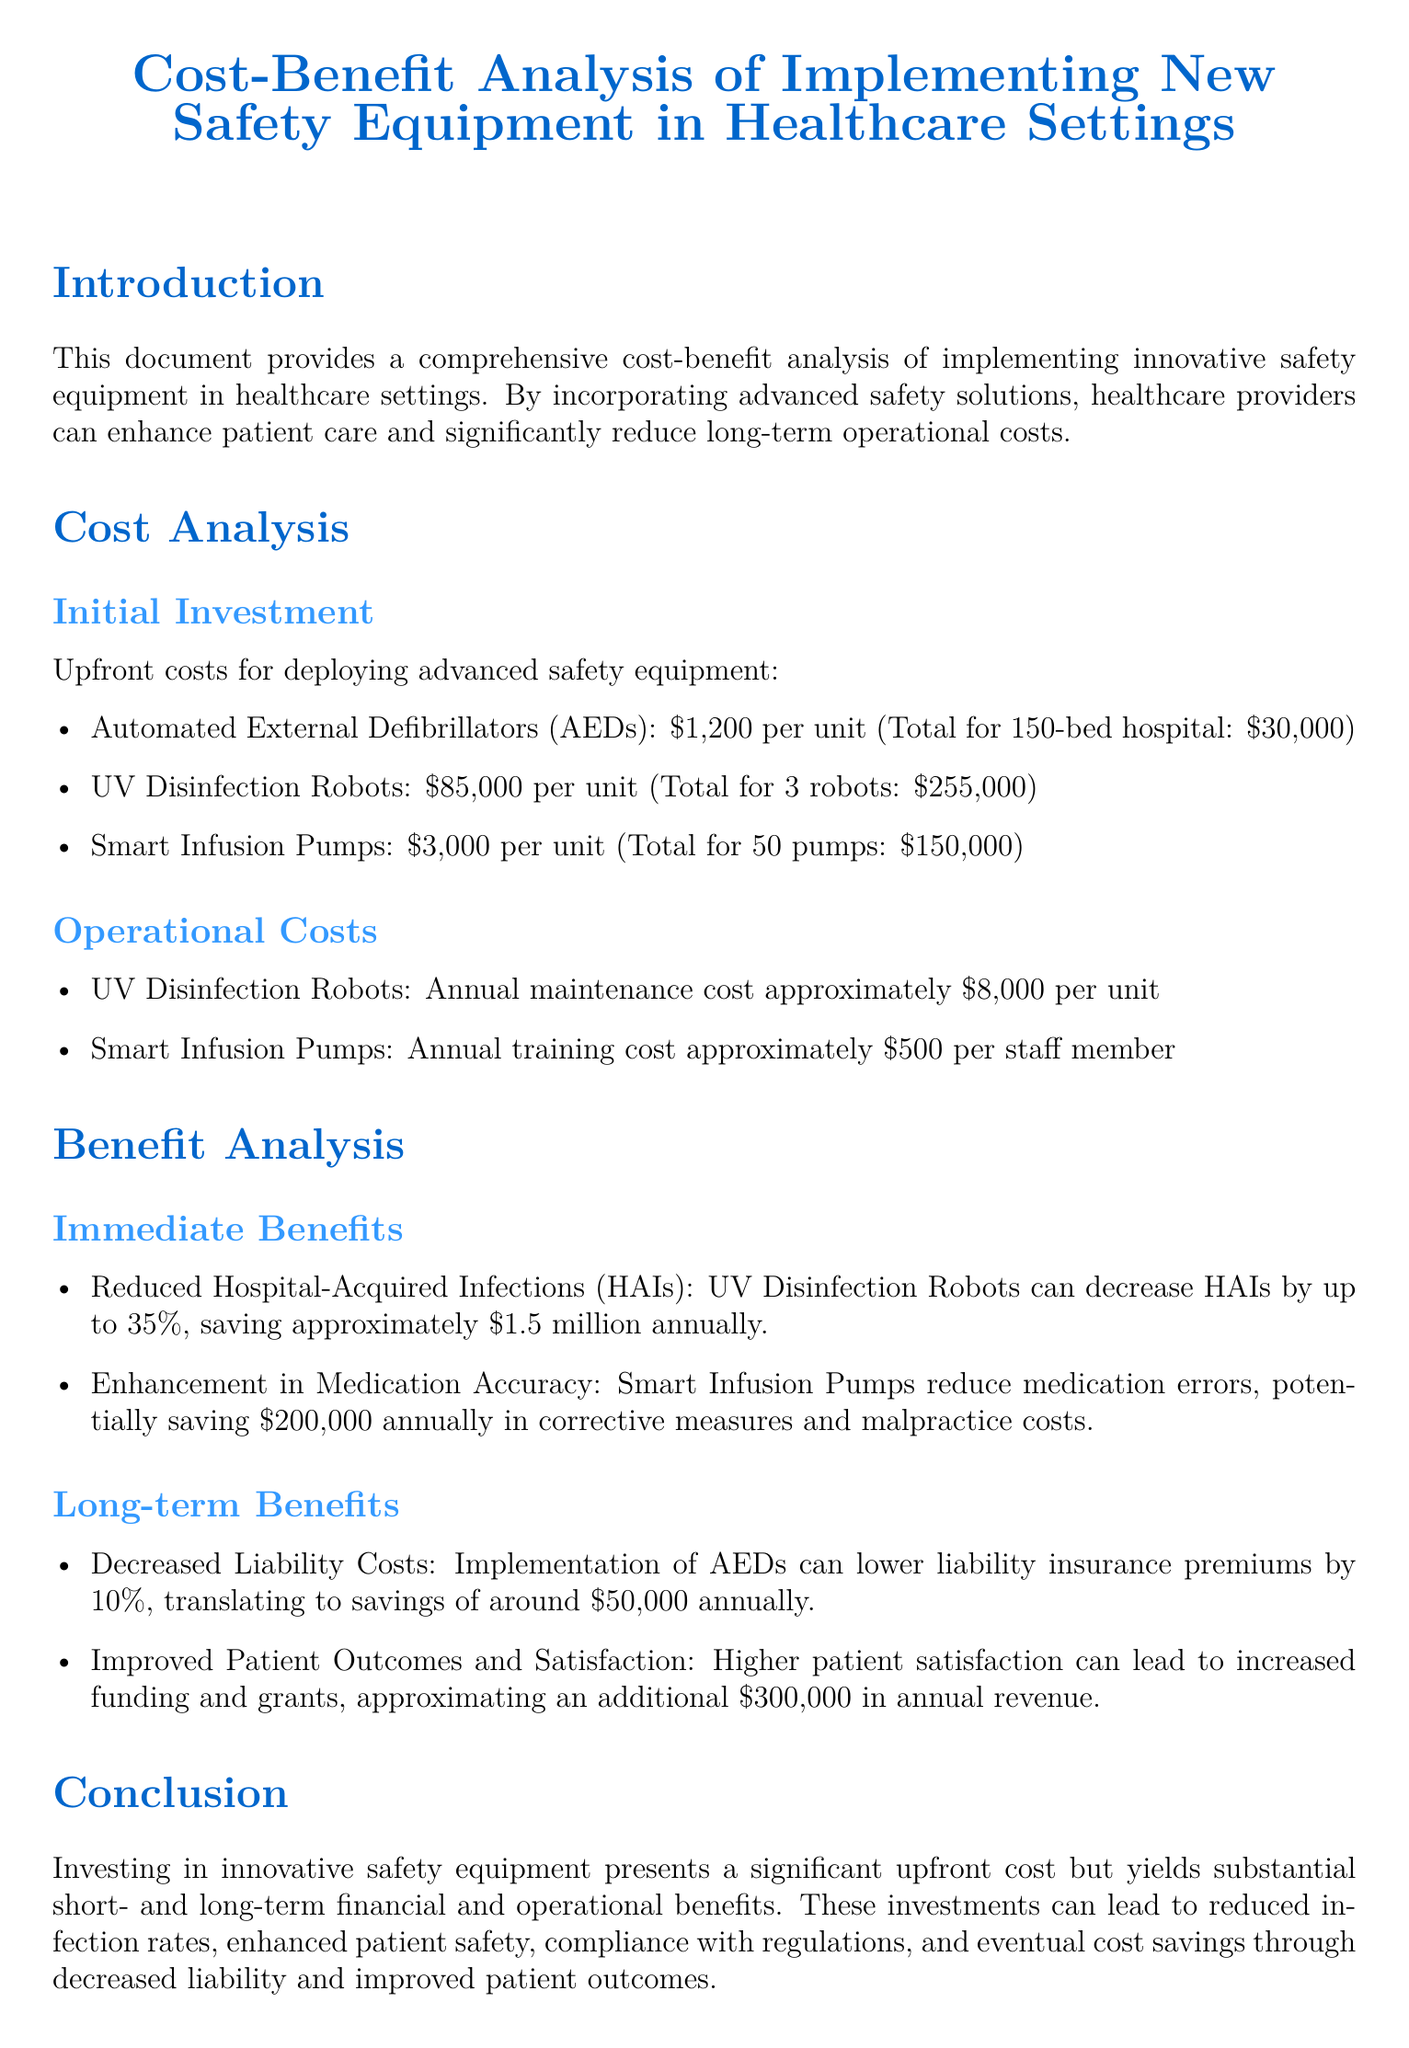What is the cost of one AED? The cost of one Automated External Defibrillator (AED) is stated as $1,200 per unit.
Answer: $1,200 What is the total cost of the UV Disinfection Robots? The document states that the total cost for 3 UV Disinfection Robots is $255,000.
Answer: $255,000 How much can UV Disinfection Robots save annually in reduced HAIs? The document indicates that UV Disinfection Robots can save approximately $1.5 million annually by decreasing HAIs.
Answer: $1.5 million What is the annual training cost for Smart Infusion Pumps? The annual training cost mentioned for Smart Infusion Pumps is approximately $500 per staff member.
Answer: $500 By what percentage can implementing AEDs lower liability insurance premiums? The document states that implementing AEDs can lower liability insurance premiums by 10%.
Answer: 10% What is the annual savings from decreased liability costs due to AED implementation? The document notes that the savings from decreased liability costs due to AED implementation is around $50,000 annually.
Answer: $50,000 What type of analysis does this document provide? The document provides a comprehensive cost-benefit analysis of implementing innovative safety equipment in healthcare settings.
Answer: Cost-benefit analysis What is one long-term benefit of implementing new safety equipment? One long-term benefit stated in the document is improved patient outcomes and satisfaction, leading to additional revenue.
Answer: Improved patient outcomes and satisfaction What can the implementation of Smart Infusion Pumps potentially save annually in malpractice costs? The document mentions that Smart Infusion Pumps can potentially save $200,000 annually in corrective measures and malpractice costs.
Answer: $200,000 What is the overall conclusion regarding investment in innovative safety equipment? The conclusion indicates that investing leads to substantial short- and long-term financial and operational benefits.
Answer: Substantial short- and long-term financial and operational benefits 